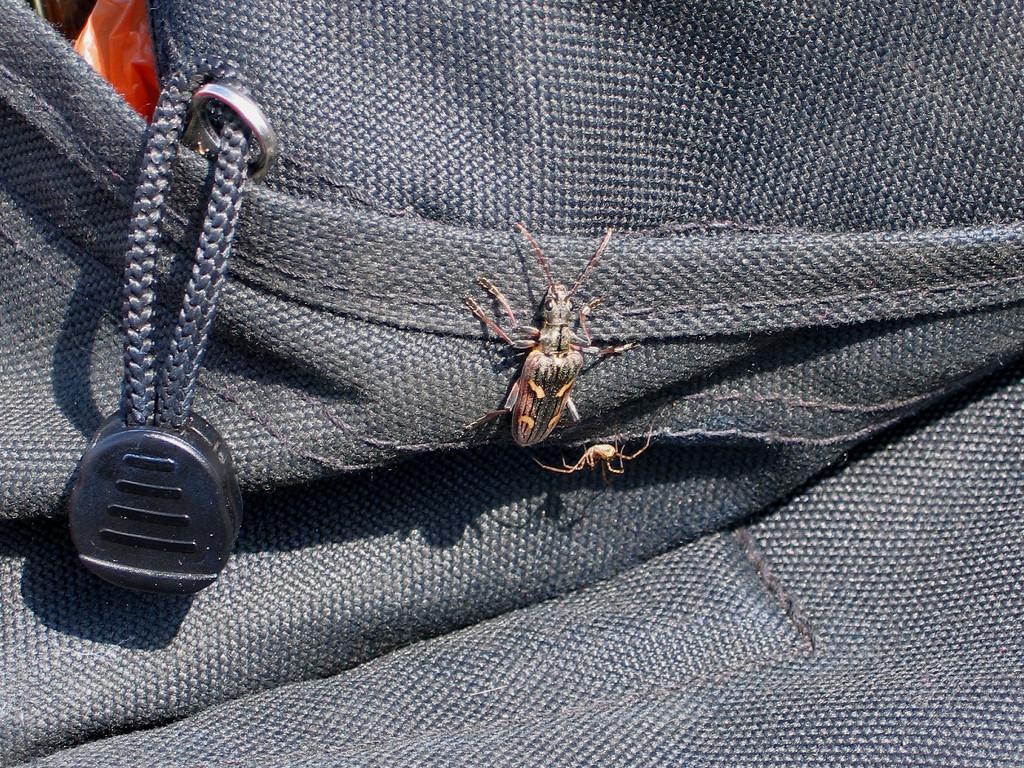How would you summarize this image in a sentence or two? In this image we can see an insect on the bag. Inside the bag there is a red color cover. 